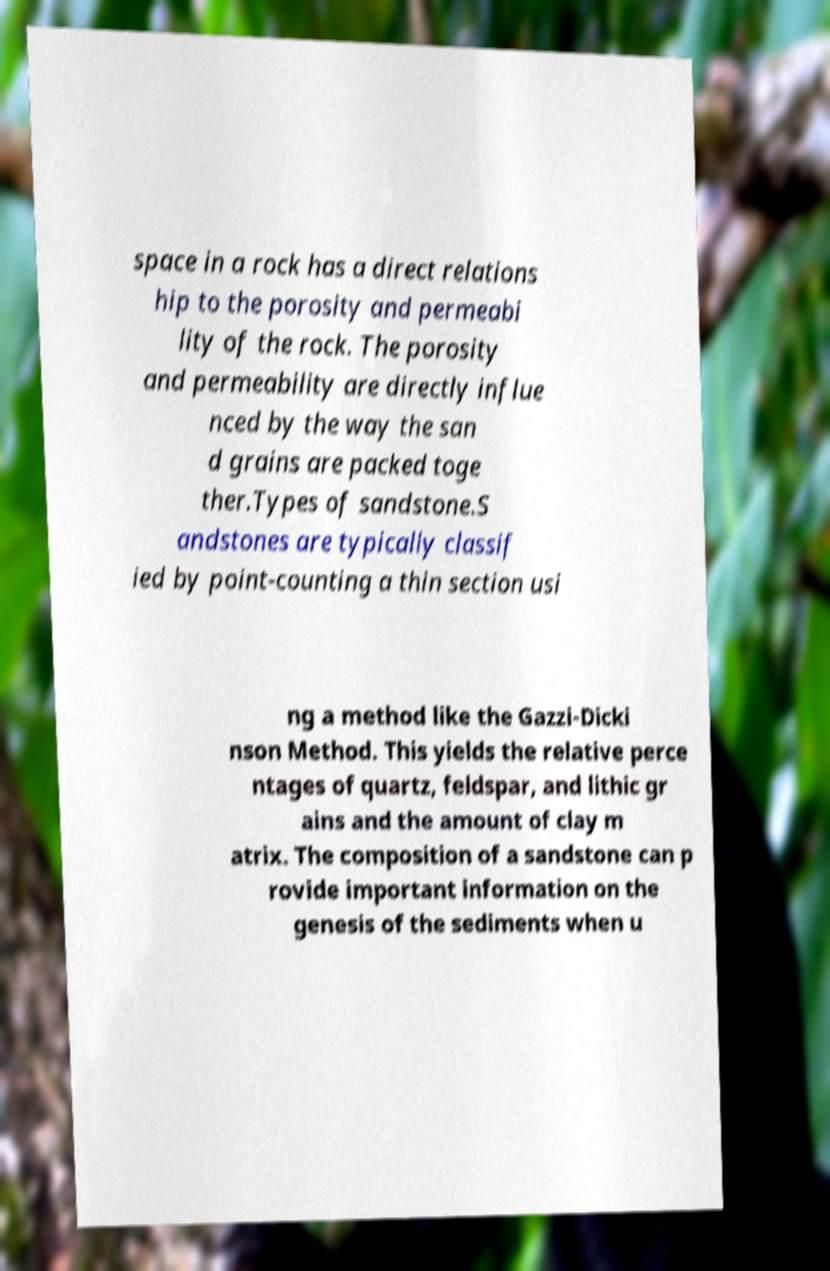Can you accurately transcribe the text from the provided image for me? space in a rock has a direct relations hip to the porosity and permeabi lity of the rock. The porosity and permeability are directly influe nced by the way the san d grains are packed toge ther.Types of sandstone.S andstones are typically classif ied by point-counting a thin section usi ng a method like the Gazzi-Dicki nson Method. This yields the relative perce ntages of quartz, feldspar, and lithic gr ains and the amount of clay m atrix. The composition of a sandstone can p rovide important information on the genesis of the sediments when u 